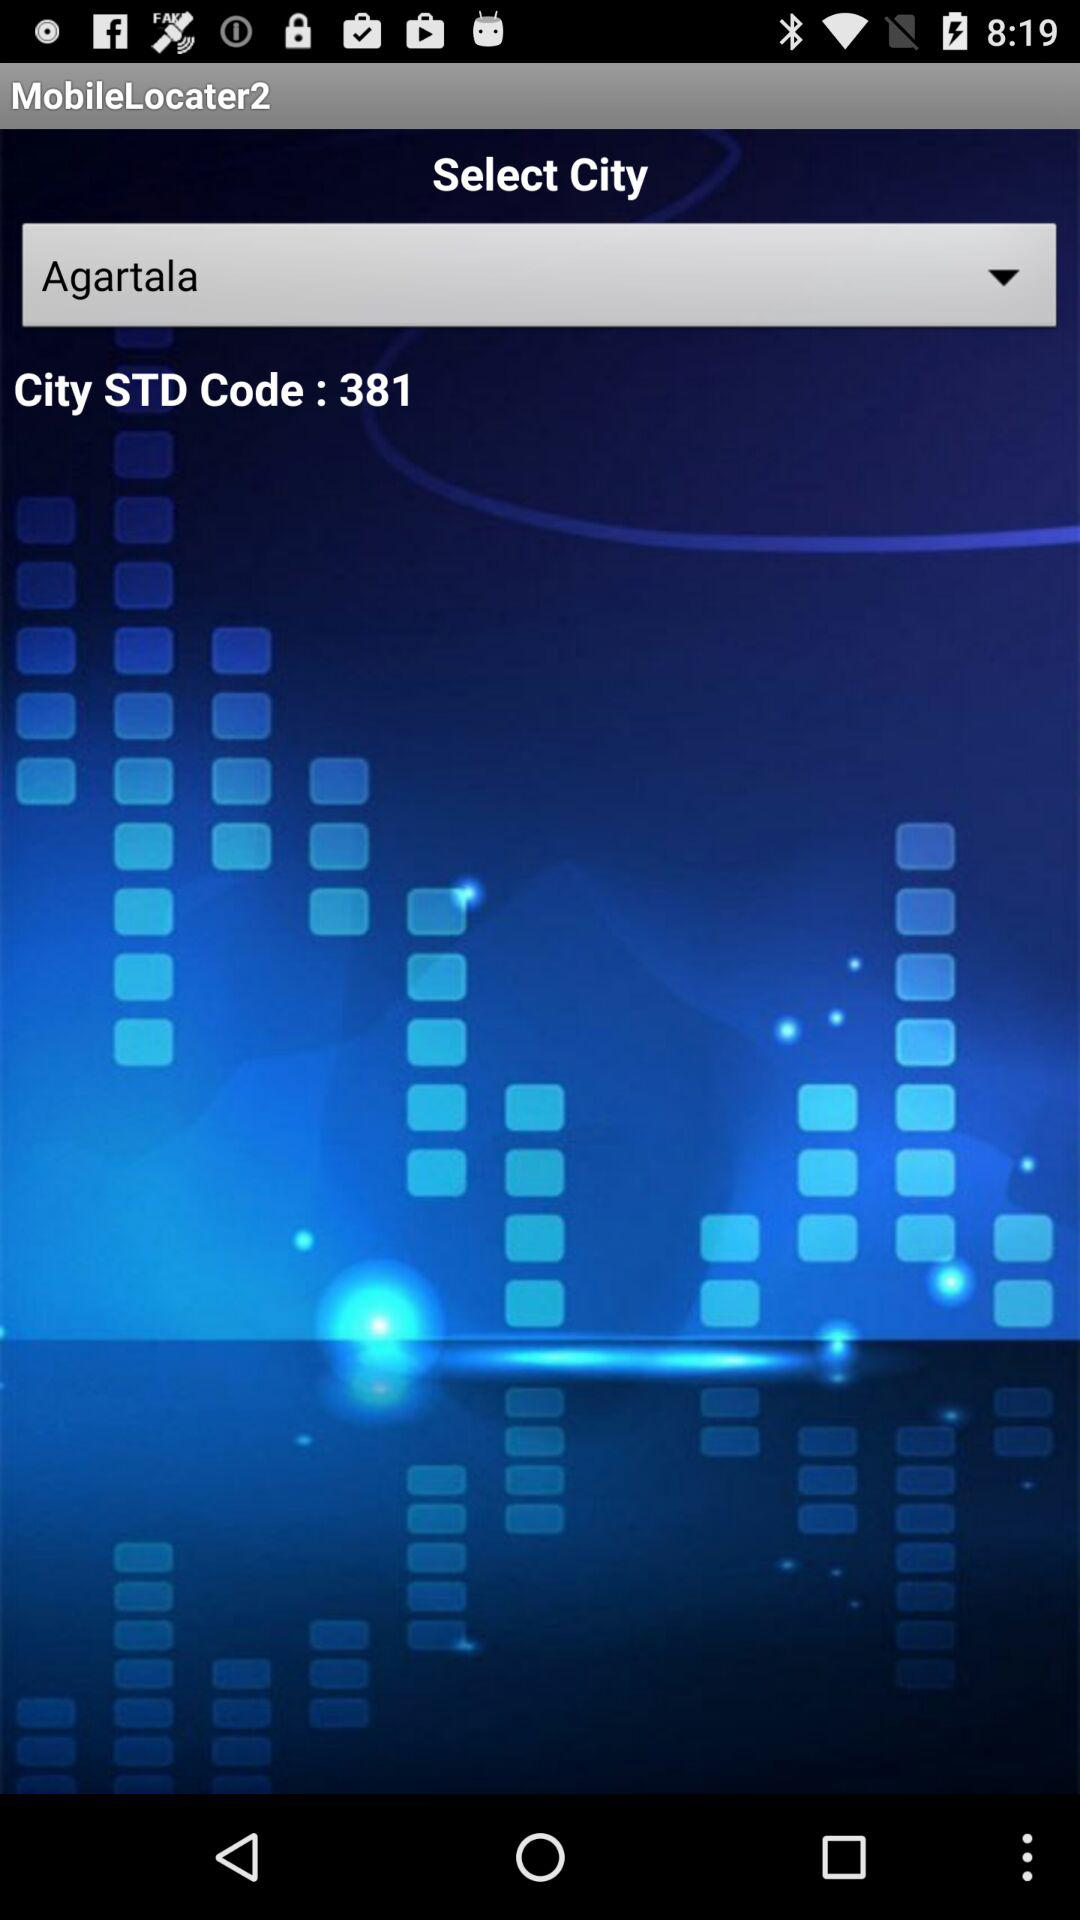Which city is selected? The selected city is Agartala. 